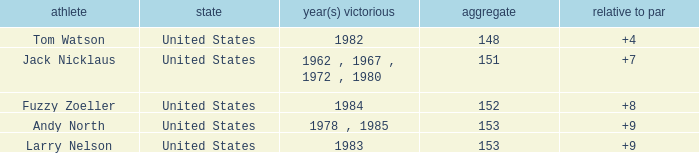What is Andy North with a To par greater than 8 Country? United States. 